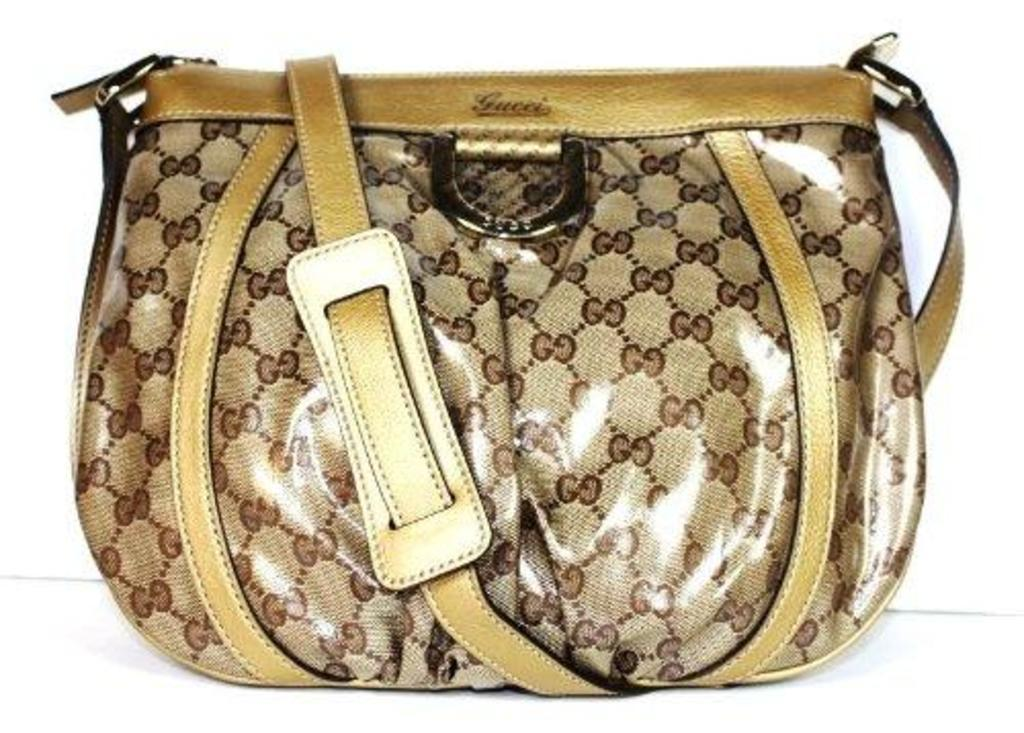What type of accessory is present in the image? There is a handbag in the image. What material is the handbag made of? The handbag is made of leather. What colors can be seen on the handbag? The handbag has a gold and brown color. What feature does the handbag have for carrying purposes? The handbag has a holder. What type of tin can be seen on the stage in the image? There is no tin or stage present in the image; it features a handbag made of leather. 